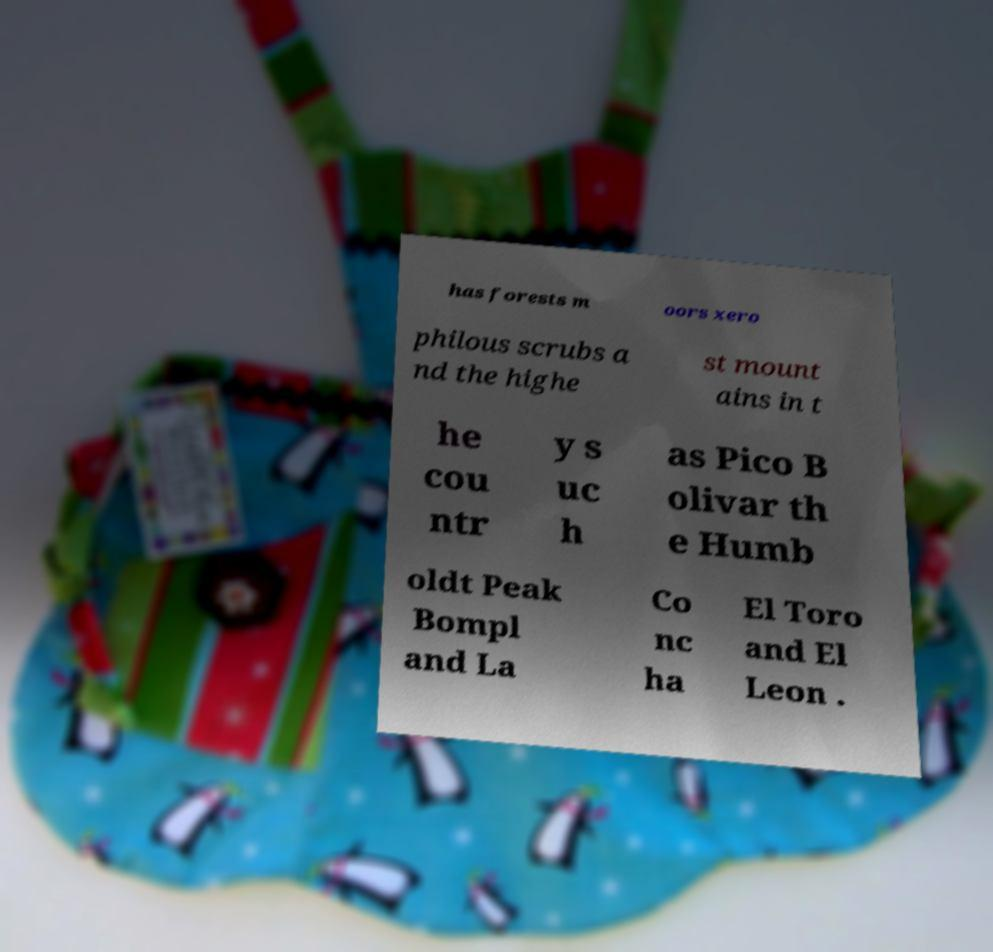Can you accurately transcribe the text from the provided image for me? has forests m oors xero philous scrubs a nd the highe st mount ains in t he cou ntr y s uc h as Pico B olivar th e Humb oldt Peak Bompl and La Co nc ha El Toro and El Leon . 